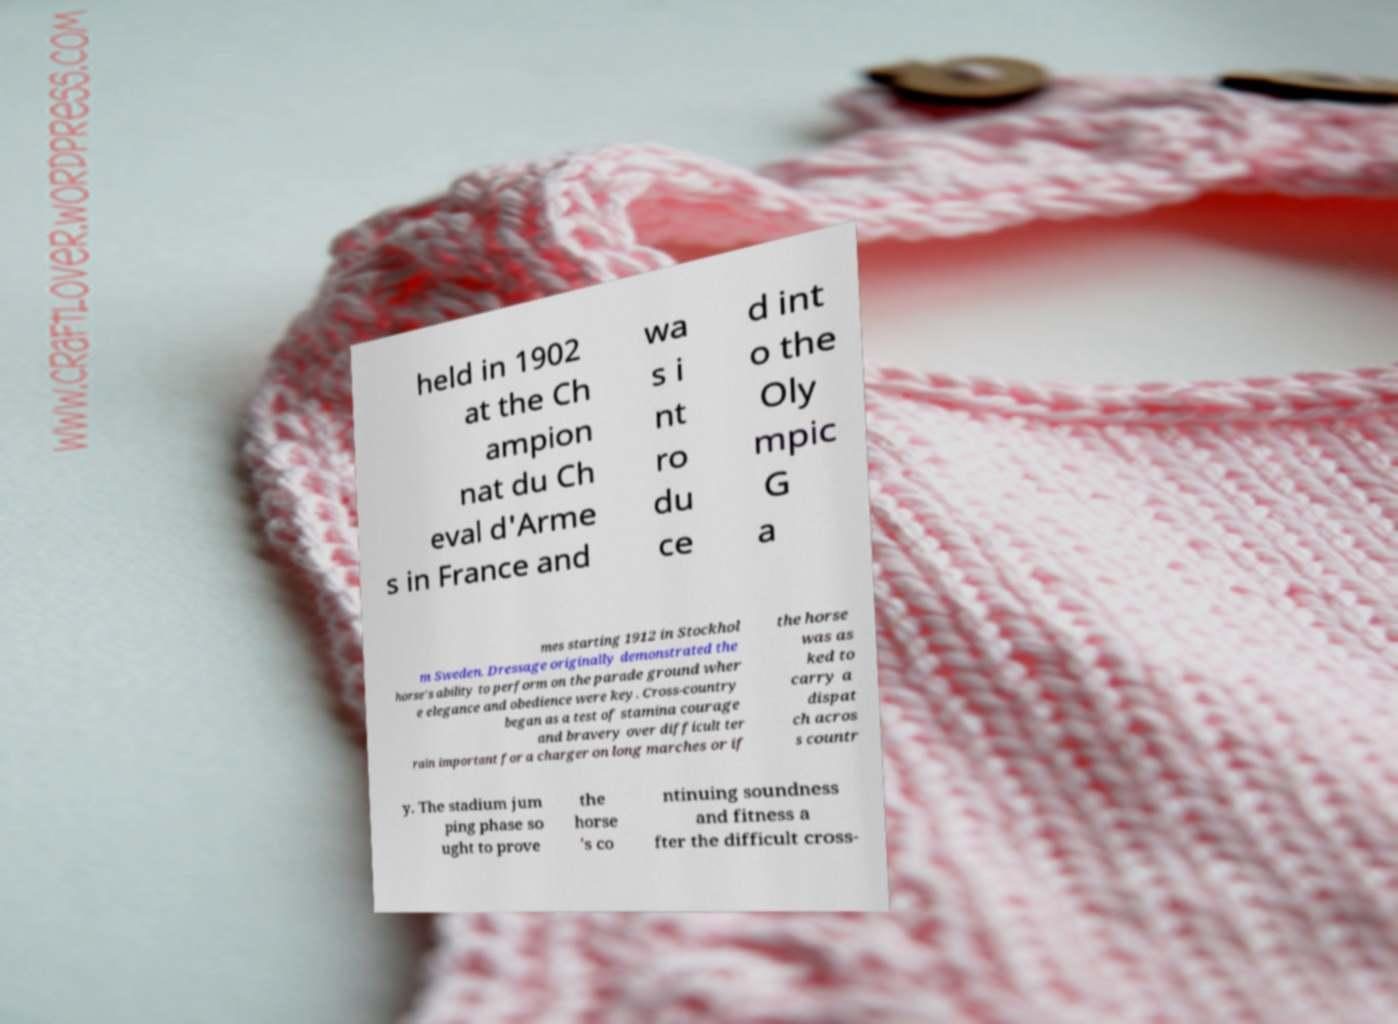Could you extract and type out the text from this image? held in 1902 at the Ch ampion nat du Ch eval d'Arme s in France and wa s i nt ro du ce d int o the Oly mpic G a mes starting 1912 in Stockhol m Sweden. Dressage originally demonstrated the horse's ability to perform on the parade ground wher e elegance and obedience were key. Cross-country began as a test of stamina courage and bravery over difficult ter rain important for a charger on long marches or if the horse was as ked to carry a dispat ch acros s countr y. The stadium jum ping phase so ught to prove the horse 's co ntinuing soundness and fitness a fter the difficult cross- 